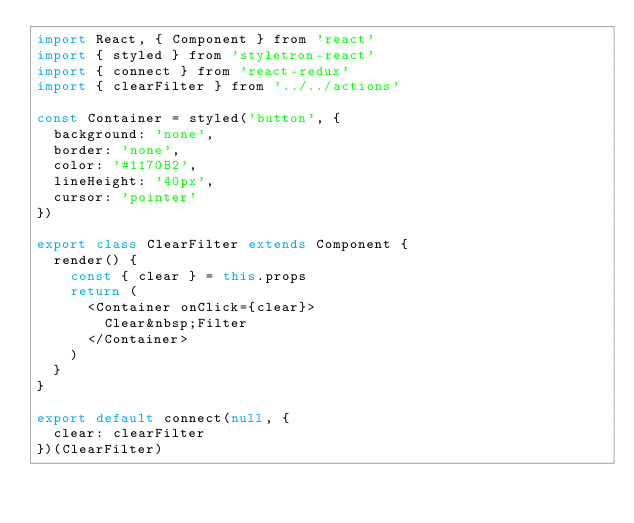<code> <loc_0><loc_0><loc_500><loc_500><_JavaScript_>import React, { Component } from 'react'
import { styled } from 'styletron-react'
import { connect } from 'react-redux'
import { clearFilter } from '../../actions'

const Container = styled('button', {
  background: 'none',
  border: 'none',
  color: '#1170B2',
  lineHeight: '40px',
  cursor: 'pointer'
})

export class ClearFilter extends Component {
  render() {
    const { clear } = this.props
    return (
      <Container onClick={clear}>
        Clear&nbsp;Filter
      </Container>
    )
  }
}

export default connect(null, {
  clear: clearFilter
})(ClearFilter)
</code> 